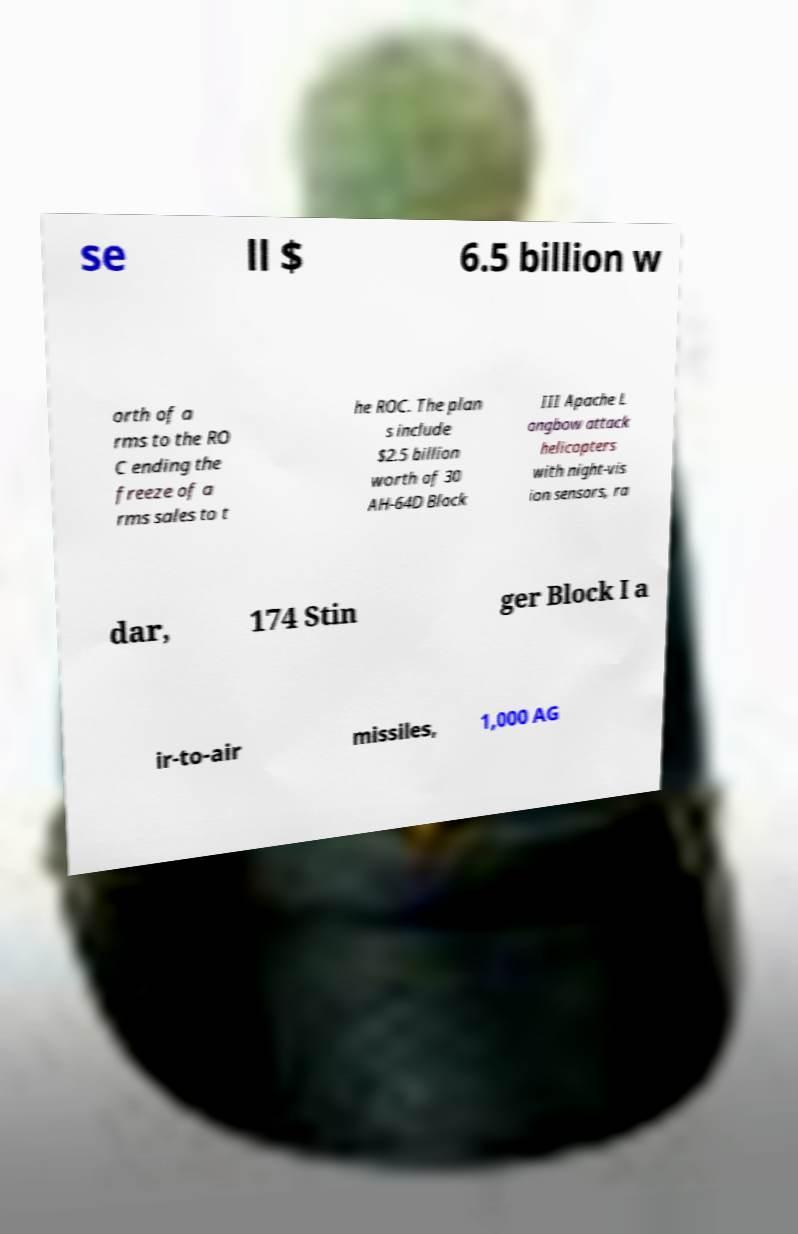Please identify and transcribe the text found in this image. se ll $ 6.5 billion w orth of a rms to the RO C ending the freeze of a rms sales to t he ROC. The plan s include $2.5 billion worth of 30 AH-64D Block III Apache L ongbow attack helicopters with night-vis ion sensors, ra dar, 174 Stin ger Block I a ir-to-air missiles, 1,000 AG 